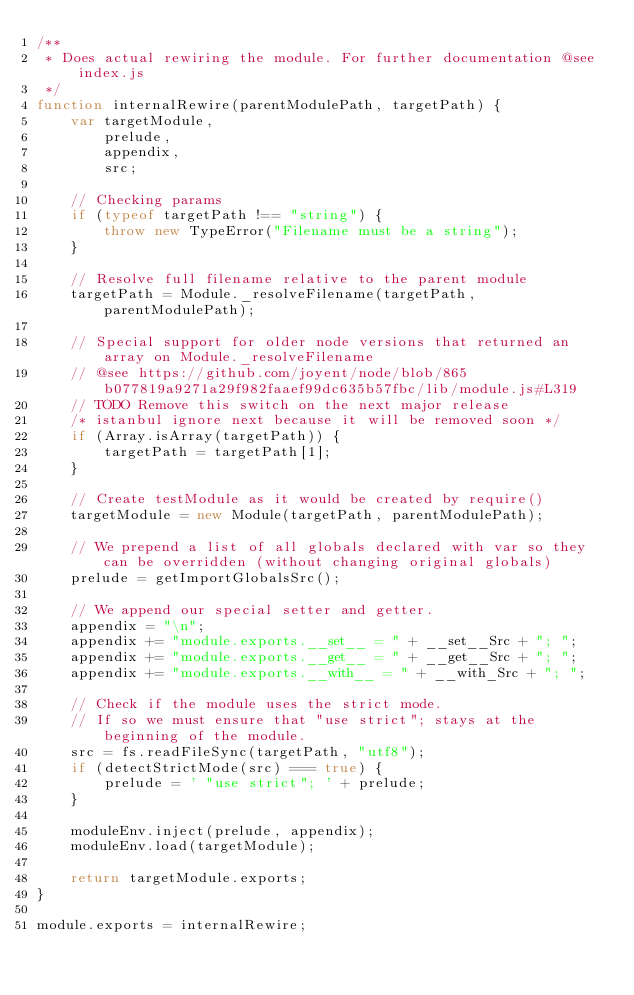Convert code to text. <code><loc_0><loc_0><loc_500><loc_500><_JavaScript_>/**
 * Does actual rewiring the module. For further documentation @see index.js
 */
function internalRewire(parentModulePath, targetPath) {
    var targetModule,
        prelude,
        appendix,
        src;

    // Checking params
    if (typeof targetPath !== "string") {
        throw new TypeError("Filename must be a string");
    }

    // Resolve full filename relative to the parent module
    targetPath = Module._resolveFilename(targetPath, parentModulePath);

    // Special support for older node versions that returned an array on Module._resolveFilename
    // @see https://github.com/joyent/node/blob/865b077819a9271a29f982faaef99dc635b57fbc/lib/module.js#L319
    // TODO Remove this switch on the next major release
    /* istanbul ignore next because it will be removed soon */
    if (Array.isArray(targetPath)) {
        targetPath = targetPath[1];
    }

    // Create testModule as it would be created by require()
    targetModule = new Module(targetPath, parentModulePath);

    // We prepend a list of all globals declared with var so they can be overridden (without changing original globals)
    prelude = getImportGlobalsSrc();

    // We append our special setter and getter.
    appendix = "\n";
    appendix += "module.exports.__set__ = " + __set__Src + "; ";
    appendix += "module.exports.__get__ = " + __get__Src + "; ";
    appendix += "module.exports.__with__ = " + __with_Src + "; ";

    // Check if the module uses the strict mode.
    // If so we must ensure that "use strict"; stays at the beginning of the module.
    src = fs.readFileSync(targetPath, "utf8");
    if (detectStrictMode(src) === true) {
        prelude = ' "use strict"; ' + prelude;
    }

    moduleEnv.inject(prelude, appendix);
    moduleEnv.load(targetModule);

    return targetModule.exports;
}

module.exports = internalRewire;
</code> 